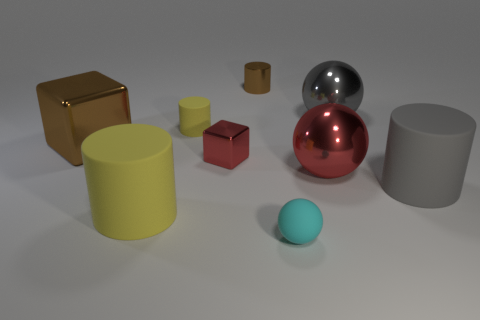Subtract all metal cylinders. How many cylinders are left? 3 Add 1 red things. How many objects exist? 10 Subtract all cylinders. How many objects are left? 5 Subtract 3 balls. How many balls are left? 0 Subtract all purple balls. Subtract all brown cylinders. How many balls are left? 3 Subtract all gray cylinders. How many red blocks are left? 1 Subtract all small red rubber cylinders. Subtract all gray metallic things. How many objects are left? 8 Add 9 tiny brown metal objects. How many tiny brown metal objects are left? 10 Add 6 cyan rubber objects. How many cyan rubber objects exist? 7 Subtract all gray cylinders. How many cylinders are left? 3 